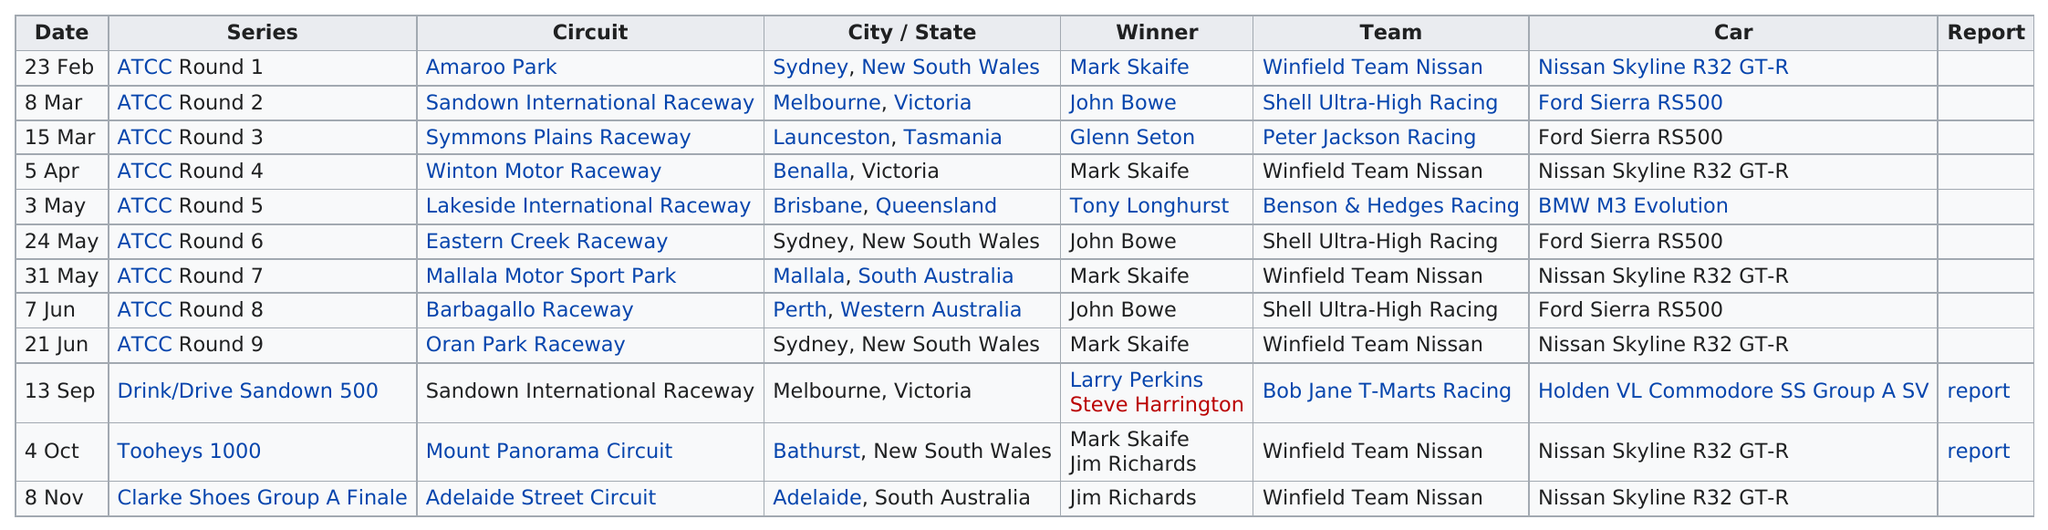Specify some key components in this picture. On March 15th, Glen Seton won. Mark Skaife, prior to the month of June, won the highest number of races. Jerry Edwards did not win at least one race. The circuit that follows Symmons Plains Raceway is Winton Motor Raceway. John Bowe won more races than Glenn Seton. 